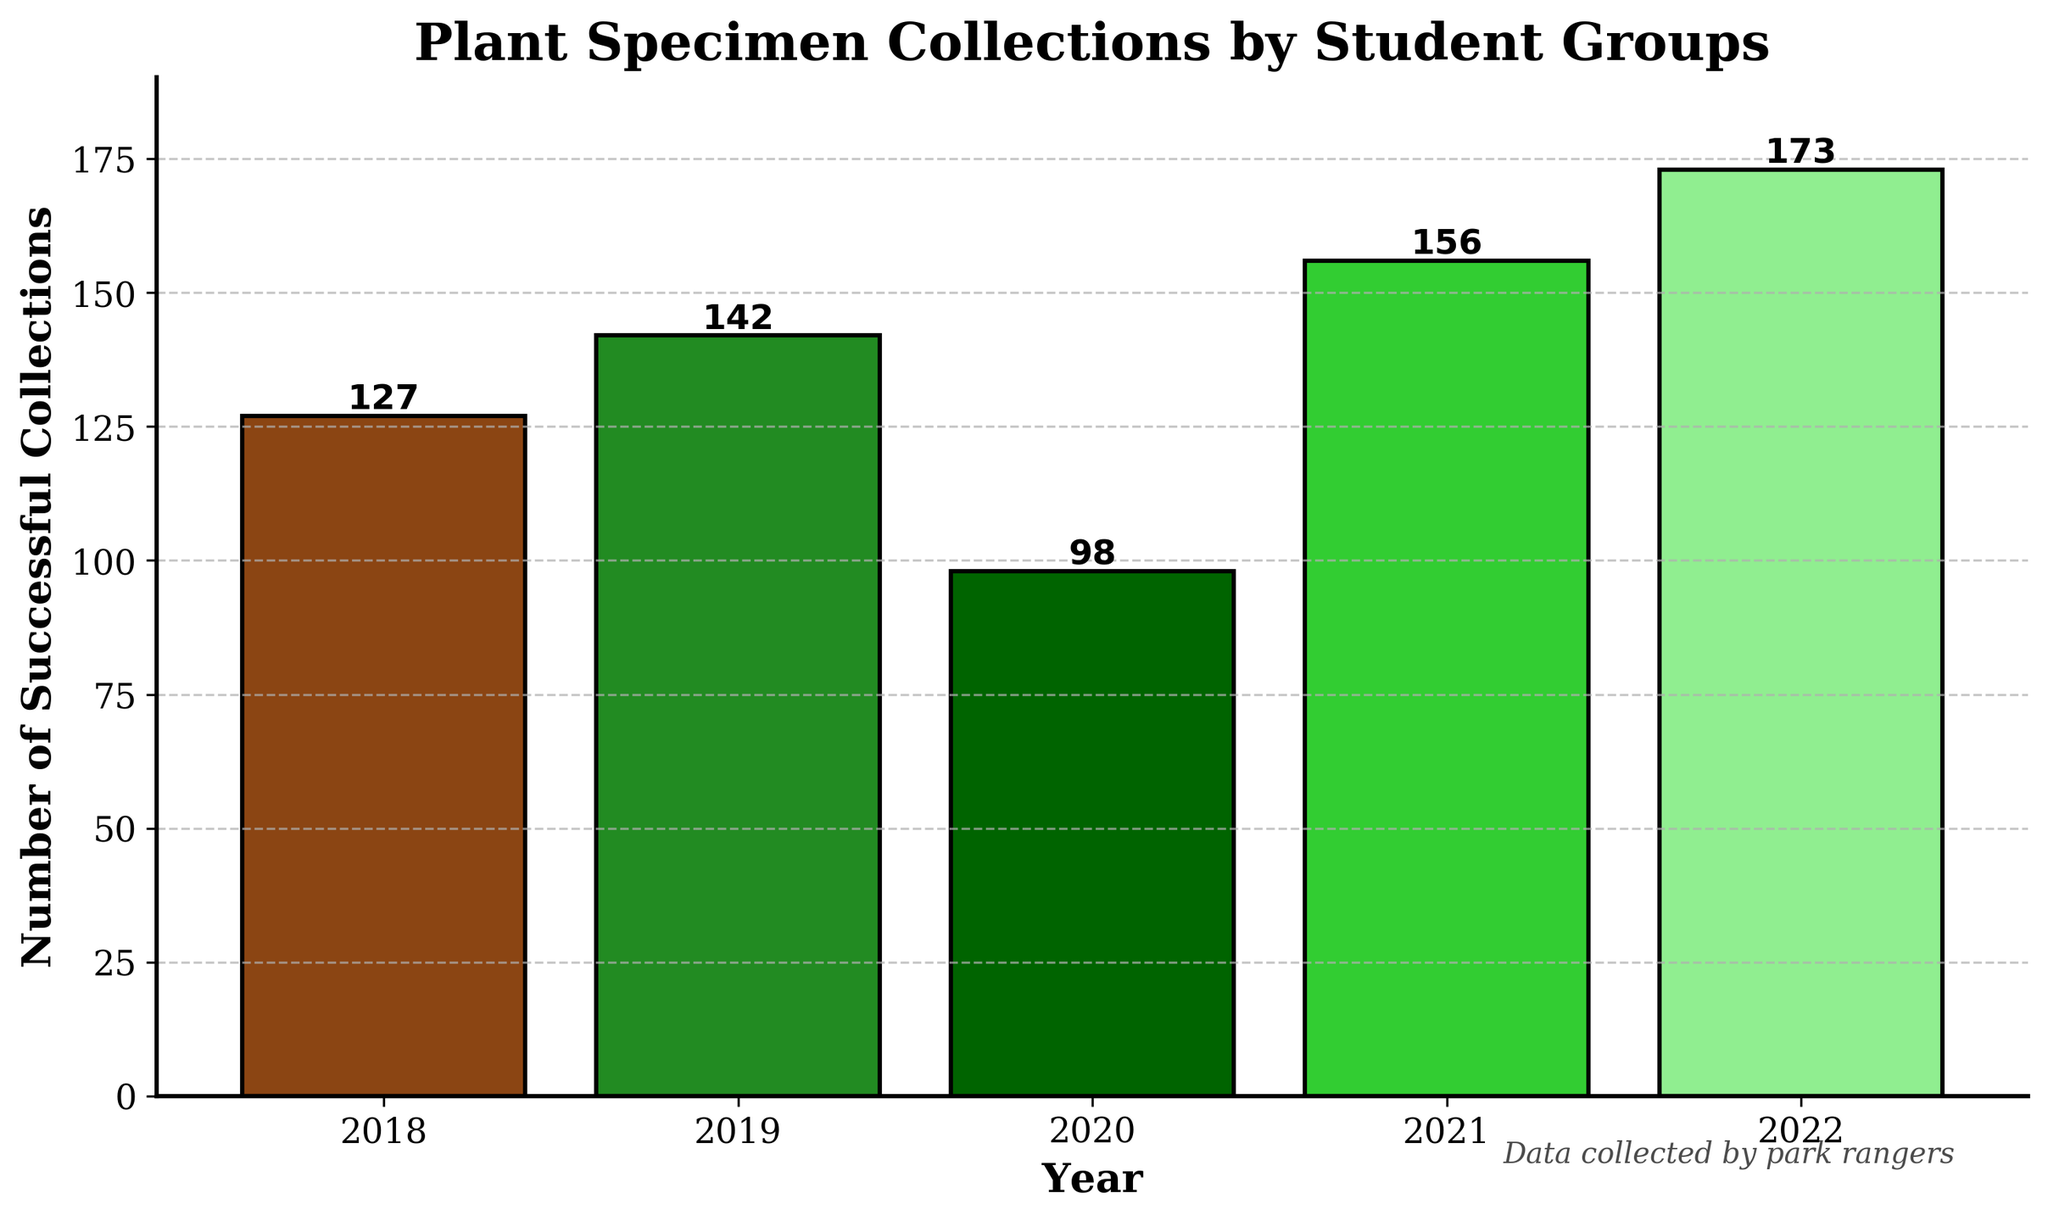What's the total number of successful plant specimen collections over the 5-year period? To find the total number of successful collections over 5 years, sum the values for each year: 127 (2018) + 142 (2019) + 98 (2020) + 156 (2021) + 173 (2022) = 696
Answer: 696 In which year was the number of successful plant specimen collections the highest? Compare the values for each year and identify the highest one. The values are: 127 (2018), 142 (2019), 98 (2020), 156 (2021), 173 (2022). The highest is 173 in 2022
Answer: 2022 What is the difference in the number of successful collections between the year 2020 and 2021? Subtract the number of collections in 2020 from the number in 2021: 156 (2021) - 98 (2020) = 58
Answer: 58 Which two years have the smallest and largest number of successful collections respectively? Compare the values for all years to identify the smallest and largest values: the smallest is 98 (2020) and the largest is 173 (2022)
Answer: 2020 and 2022 What’s the average number of successful plant specimen collections per year over the 5-year period? Sum the total number of collections and divide by the number of years: (127 + 142 + 98 + 156 + 173) / 5. Calculation: 696 / 5 = approx. 139.2
Answer: 139.2 How did the number of successful collections change from 2018 to 2019? Subtract the number of collections in 2018 from the number in 2019: 142 (2019) - 127 (2018) = 15
Answer: Increased by 15 Are there any consecutive years where the number of collections decreased? Check the values for consecutive years to find any decreases: From 2018 to 2019 (127 to 142: Increase), 2019 to 2020 (142 to 98: Decrease), 2020 to 2021 (98 to 156: Increase), 2021 to 2022 (156 to 173: Increase). There is a decrease from 2019 to 2020.
Answer: Yes Which year had the lowest number of successful collections, and what visual attribute makes it easiest to identify this year? The year 2020 had the lowest number with 98 collections. The shortest bar in the bar chart corresponds to 2020, making it visually identifiable.
Answer: 2020 By how much did the number of collections increase from 2019 to 2022? Subtract the number of collections in 2019 from the number in 2022: 173 (2022) - 142 (2019) = 31
Answer: 31 What’s the percentage increase in the number of successful collections from 2020 to 2022? First, find the increase: 173 (2022) - 98 (2020) = 75. Next, calculate the percentage increase relative to 2020: (75 / 98) * 100 = approx. 76.53%
Answer: 76.53% 